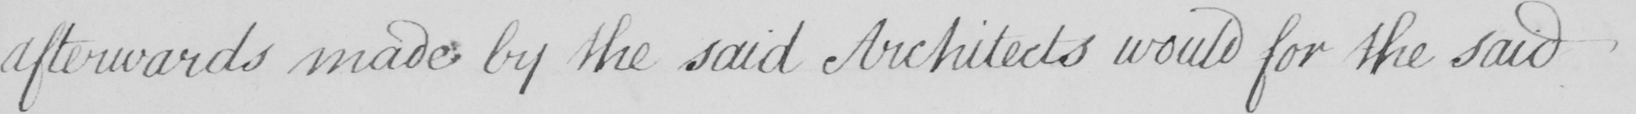Please provide the text content of this handwritten line. afterwards made by the said Architects would for the said 